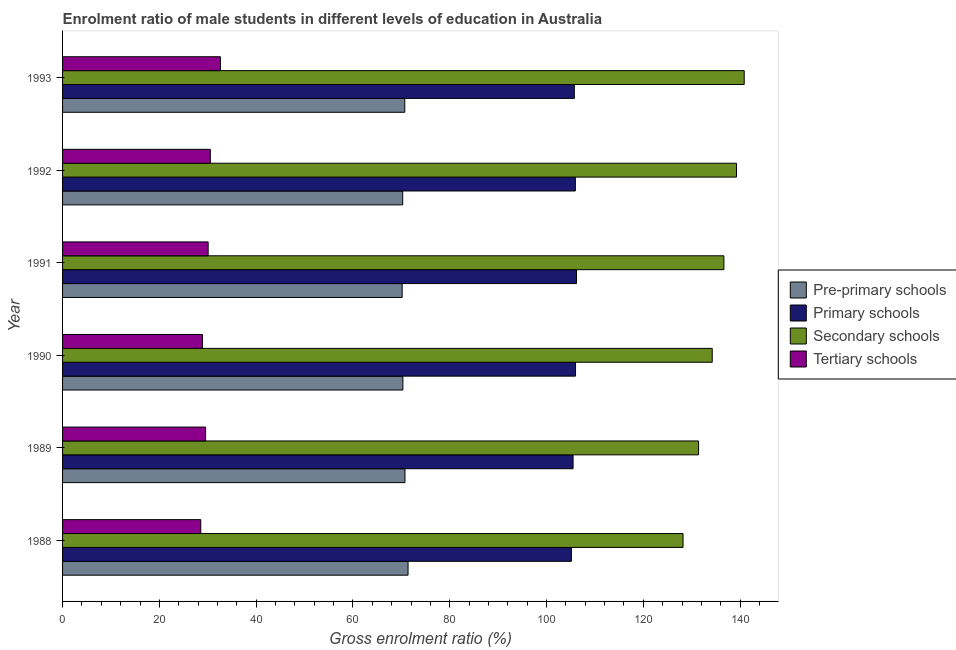How many different coloured bars are there?
Provide a succinct answer. 4. Are the number of bars per tick equal to the number of legend labels?
Make the answer very short. Yes. How many bars are there on the 6th tick from the bottom?
Your answer should be very brief. 4. In how many cases, is the number of bars for a given year not equal to the number of legend labels?
Give a very brief answer. 0. What is the gross enrolment ratio(female) in tertiary schools in 1991?
Make the answer very short. 30.08. Across all years, what is the maximum gross enrolment ratio(female) in primary schools?
Offer a terse response. 106.19. Across all years, what is the minimum gross enrolment ratio(female) in pre-primary schools?
Offer a terse response. 70.17. In which year was the gross enrolment ratio(female) in tertiary schools maximum?
Offer a terse response. 1993. What is the total gross enrolment ratio(female) in secondary schools in the graph?
Your answer should be very brief. 810.62. What is the difference between the gross enrolment ratio(female) in pre-primary schools in 1988 and that in 1989?
Your response must be concise. 0.64. What is the difference between the gross enrolment ratio(female) in tertiary schools in 1990 and the gross enrolment ratio(female) in pre-primary schools in 1993?
Your response must be concise. -41.79. What is the average gross enrolment ratio(female) in pre-primary schools per year?
Provide a short and direct response. 70.6. In the year 1989, what is the difference between the gross enrolment ratio(female) in pre-primary schools and gross enrolment ratio(female) in primary schools?
Offer a terse response. -34.74. What is the ratio of the gross enrolment ratio(female) in secondary schools in 1988 to that in 1990?
Make the answer very short. 0.95. Is the gross enrolment ratio(female) in primary schools in 1992 less than that in 1993?
Offer a terse response. No. Is the difference between the gross enrolment ratio(female) in tertiary schools in 1988 and 1991 greater than the difference between the gross enrolment ratio(female) in primary schools in 1988 and 1991?
Your answer should be compact. No. What is the difference between the highest and the second highest gross enrolment ratio(female) in tertiary schools?
Offer a terse response. 2.08. What is the difference between the highest and the lowest gross enrolment ratio(female) in secondary schools?
Ensure brevity in your answer.  12.64. In how many years, is the gross enrolment ratio(female) in tertiary schools greater than the average gross enrolment ratio(female) in tertiary schools taken over all years?
Offer a terse response. 3. Is the sum of the gross enrolment ratio(female) in tertiary schools in 1988 and 1991 greater than the maximum gross enrolment ratio(female) in secondary schools across all years?
Make the answer very short. No. Is it the case that in every year, the sum of the gross enrolment ratio(female) in pre-primary schools and gross enrolment ratio(female) in tertiary schools is greater than the sum of gross enrolment ratio(female) in primary schools and gross enrolment ratio(female) in secondary schools?
Your answer should be compact. No. What does the 4th bar from the top in 1991 represents?
Offer a terse response. Pre-primary schools. What does the 2nd bar from the bottom in 1991 represents?
Offer a terse response. Primary schools. Is it the case that in every year, the sum of the gross enrolment ratio(female) in pre-primary schools and gross enrolment ratio(female) in primary schools is greater than the gross enrolment ratio(female) in secondary schools?
Your answer should be very brief. Yes. How many bars are there?
Provide a succinct answer. 24. Are all the bars in the graph horizontal?
Offer a terse response. Yes. Are the values on the major ticks of X-axis written in scientific E-notation?
Offer a very short reply. No. Does the graph contain any zero values?
Ensure brevity in your answer.  No. Does the graph contain grids?
Provide a short and direct response. No. Where does the legend appear in the graph?
Ensure brevity in your answer.  Center right. How many legend labels are there?
Your answer should be compact. 4. How are the legend labels stacked?
Offer a very short reply. Vertical. What is the title of the graph?
Keep it short and to the point. Enrolment ratio of male students in different levels of education in Australia. Does "Industry" appear as one of the legend labels in the graph?
Your answer should be very brief. No. What is the label or title of the X-axis?
Offer a terse response. Gross enrolment ratio (%). What is the Gross enrolment ratio (%) in Pre-primary schools in 1988?
Your response must be concise. 71.39. What is the Gross enrolment ratio (%) of Primary schools in 1988?
Give a very brief answer. 105.14. What is the Gross enrolment ratio (%) in Secondary schools in 1988?
Your answer should be very brief. 128.21. What is the Gross enrolment ratio (%) in Tertiary schools in 1988?
Offer a very short reply. 28.56. What is the Gross enrolment ratio (%) of Pre-primary schools in 1989?
Your response must be concise. 70.75. What is the Gross enrolment ratio (%) in Primary schools in 1989?
Your answer should be very brief. 105.49. What is the Gross enrolment ratio (%) of Secondary schools in 1989?
Your answer should be very brief. 131.42. What is the Gross enrolment ratio (%) of Tertiary schools in 1989?
Provide a short and direct response. 29.56. What is the Gross enrolment ratio (%) in Pre-primary schools in 1990?
Your answer should be very brief. 70.32. What is the Gross enrolment ratio (%) of Primary schools in 1990?
Offer a terse response. 105.99. What is the Gross enrolment ratio (%) in Secondary schools in 1990?
Make the answer very short. 134.24. What is the Gross enrolment ratio (%) of Tertiary schools in 1990?
Your response must be concise. 28.92. What is the Gross enrolment ratio (%) of Pre-primary schools in 1991?
Offer a terse response. 70.17. What is the Gross enrolment ratio (%) of Primary schools in 1991?
Keep it short and to the point. 106.19. What is the Gross enrolment ratio (%) of Secondary schools in 1991?
Your response must be concise. 136.65. What is the Gross enrolment ratio (%) in Tertiary schools in 1991?
Give a very brief answer. 30.08. What is the Gross enrolment ratio (%) of Pre-primary schools in 1992?
Keep it short and to the point. 70.28. What is the Gross enrolment ratio (%) in Primary schools in 1992?
Your response must be concise. 105.96. What is the Gross enrolment ratio (%) of Secondary schools in 1992?
Offer a terse response. 139.25. What is the Gross enrolment ratio (%) in Tertiary schools in 1992?
Make the answer very short. 30.53. What is the Gross enrolment ratio (%) of Pre-primary schools in 1993?
Make the answer very short. 70.71. What is the Gross enrolment ratio (%) of Primary schools in 1993?
Ensure brevity in your answer.  105.75. What is the Gross enrolment ratio (%) in Secondary schools in 1993?
Provide a succinct answer. 140.85. What is the Gross enrolment ratio (%) of Tertiary schools in 1993?
Provide a succinct answer. 32.62. Across all years, what is the maximum Gross enrolment ratio (%) of Pre-primary schools?
Offer a terse response. 71.39. Across all years, what is the maximum Gross enrolment ratio (%) of Primary schools?
Offer a very short reply. 106.19. Across all years, what is the maximum Gross enrolment ratio (%) of Secondary schools?
Ensure brevity in your answer.  140.85. Across all years, what is the maximum Gross enrolment ratio (%) in Tertiary schools?
Your answer should be compact. 32.62. Across all years, what is the minimum Gross enrolment ratio (%) in Pre-primary schools?
Your answer should be very brief. 70.17. Across all years, what is the minimum Gross enrolment ratio (%) of Primary schools?
Your answer should be very brief. 105.14. Across all years, what is the minimum Gross enrolment ratio (%) in Secondary schools?
Make the answer very short. 128.21. Across all years, what is the minimum Gross enrolment ratio (%) in Tertiary schools?
Ensure brevity in your answer.  28.56. What is the total Gross enrolment ratio (%) in Pre-primary schools in the graph?
Provide a short and direct response. 423.62. What is the total Gross enrolment ratio (%) of Primary schools in the graph?
Keep it short and to the point. 634.52. What is the total Gross enrolment ratio (%) of Secondary schools in the graph?
Keep it short and to the point. 810.62. What is the total Gross enrolment ratio (%) in Tertiary schools in the graph?
Your answer should be very brief. 180.26. What is the difference between the Gross enrolment ratio (%) of Pre-primary schools in 1988 and that in 1989?
Your answer should be very brief. 0.64. What is the difference between the Gross enrolment ratio (%) in Primary schools in 1988 and that in 1989?
Provide a short and direct response. -0.35. What is the difference between the Gross enrolment ratio (%) in Secondary schools in 1988 and that in 1989?
Provide a short and direct response. -3.21. What is the difference between the Gross enrolment ratio (%) of Tertiary schools in 1988 and that in 1989?
Provide a short and direct response. -1. What is the difference between the Gross enrolment ratio (%) of Pre-primary schools in 1988 and that in 1990?
Offer a very short reply. 1.07. What is the difference between the Gross enrolment ratio (%) of Primary schools in 1988 and that in 1990?
Ensure brevity in your answer.  -0.86. What is the difference between the Gross enrolment ratio (%) in Secondary schools in 1988 and that in 1990?
Offer a terse response. -6.03. What is the difference between the Gross enrolment ratio (%) of Tertiary schools in 1988 and that in 1990?
Provide a short and direct response. -0.36. What is the difference between the Gross enrolment ratio (%) in Pre-primary schools in 1988 and that in 1991?
Give a very brief answer. 1.22. What is the difference between the Gross enrolment ratio (%) of Primary schools in 1988 and that in 1991?
Keep it short and to the point. -1.05. What is the difference between the Gross enrolment ratio (%) of Secondary schools in 1988 and that in 1991?
Keep it short and to the point. -8.45. What is the difference between the Gross enrolment ratio (%) of Tertiary schools in 1988 and that in 1991?
Provide a short and direct response. -1.53. What is the difference between the Gross enrolment ratio (%) of Pre-primary schools in 1988 and that in 1992?
Your answer should be very brief. 1.11. What is the difference between the Gross enrolment ratio (%) of Primary schools in 1988 and that in 1992?
Give a very brief answer. -0.82. What is the difference between the Gross enrolment ratio (%) in Secondary schools in 1988 and that in 1992?
Provide a short and direct response. -11.05. What is the difference between the Gross enrolment ratio (%) in Tertiary schools in 1988 and that in 1992?
Offer a very short reply. -1.98. What is the difference between the Gross enrolment ratio (%) in Pre-primary schools in 1988 and that in 1993?
Your answer should be compact. 0.68. What is the difference between the Gross enrolment ratio (%) in Primary schools in 1988 and that in 1993?
Offer a terse response. -0.61. What is the difference between the Gross enrolment ratio (%) in Secondary schools in 1988 and that in 1993?
Provide a short and direct response. -12.64. What is the difference between the Gross enrolment ratio (%) of Tertiary schools in 1988 and that in 1993?
Make the answer very short. -4.06. What is the difference between the Gross enrolment ratio (%) in Pre-primary schools in 1989 and that in 1990?
Your answer should be very brief. 0.43. What is the difference between the Gross enrolment ratio (%) in Primary schools in 1989 and that in 1990?
Provide a succinct answer. -0.51. What is the difference between the Gross enrolment ratio (%) of Secondary schools in 1989 and that in 1990?
Give a very brief answer. -2.82. What is the difference between the Gross enrolment ratio (%) of Tertiary schools in 1989 and that in 1990?
Your answer should be very brief. 0.64. What is the difference between the Gross enrolment ratio (%) of Pre-primary schools in 1989 and that in 1991?
Provide a succinct answer. 0.58. What is the difference between the Gross enrolment ratio (%) of Primary schools in 1989 and that in 1991?
Your answer should be compact. -0.7. What is the difference between the Gross enrolment ratio (%) in Secondary schools in 1989 and that in 1991?
Provide a short and direct response. -5.23. What is the difference between the Gross enrolment ratio (%) of Tertiary schools in 1989 and that in 1991?
Ensure brevity in your answer.  -0.53. What is the difference between the Gross enrolment ratio (%) in Pre-primary schools in 1989 and that in 1992?
Make the answer very short. 0.47. What is the difference between the Gross enrolment ratio (%) of Primary schools in 1989 and that in 1992?
Make the answer very short. -0.47. What is the difference between the Gross enrolment ratio (%) in Secondary schools in 1989 and that in 1992?
Your answer should be compact. -7.84. What is the difference between the Gross enrolment ratio (%) in Tertiary schools in 1989 and that in 1992?
Offer a terse response. -0.98. What is the difference between the Gross enrolment ratio (%) in Pre-primary schools in 1989 and that in 1993?
Offer a terse response. 0.04. What is the difference between the Gross enrolment ratio (%) in Primary schools in 1989 and that in 1993?
Make the answer very short. -0.26. What is the difference between the Gross enrolment ratio (%) in Secondary schools in 1989 and that in 1993?
Offer a very short reply. -9.43. What is the difference between the Gross enrolment ratio (%) in Tertiary schools in 1989 and that in 1993?
Ensure brevity in your answer.  -3.06. What is the difference between the Gross enrolment ratio (%) of Pre-primary schools in 1990 and that in 1991?
Keep it short and to the point. 0.15. What is the difference between the Gross enrolment ratio (%) in Primary schools in 1990 and that in 1991?
Your answer should be very brief. -0.2. What is the difference between the Gross enrolment ratio (%) of Secondary schools in 1990 and that in 1991?
Keep it short and to the point. -2.41. What is the difference between the Gross enrolment ratio (%) in Tertiary schools in 1990 and that in 1991?
Your answer should be very brief. -1.17. What is the difference between the Gross enrolment ratio (%) in Pre-primary schools in 1990 and that in 1992?
Keep it short and to the point. 0.03. What is the difference between the Gross enrolment ratio (%) in Primary schools in 1990 and that in 1992?
Your answer should be compact. 0.04. What is the difference between the Gross enrolment ratio (%) of Secondary schools in 1990 and that in 1992?
Make the answer very short. -5.01. What is the difference between the Gross enrolment ratio (%) of Tertiary schools in 1990 and that in 1992?
Offer a very short reply. -1.62. What is the difference between the Gross enrolment ratio (%) in Pre-primary schools in 1990 and that in 1993?
Provide a succinct answer. -0.39. What is the difference between the Gross enrolment ratio (%) of Primary schools in 1990 and that in 1993?
Offer a terse response. 0.25. What is the difference between the Gross enrolment ratio (%) of Secondary schools in 1990 and that in 1993?
Keep it short and to the point. -6.61. What is the difference between the Gross enrolment ratio (%) of Tertiary schools in 1990 and that in 1993?
Provide a succinct answer. -3.7. What is the difference between the Gross enrolment ratio (%) in Pre-primary schools in 1991 and that in 1992?
Offer a very short reply. -0.11. What is the difference between the Gross enrolment ratio (%) of Primary schools in 1991 and that in 1992?
Provide a succinct answer. 0.23. What is the difference between the Gross enrolment ratio (%) of Secondary schools in 1991 and that in 1992?
Offer a terse response. -2.6. What is the difference between the Gross enrolment ratio (%) of Tertiary schools in 1991 and that in 1992?
Provide a short and direct response. -0.45. What is the difference between the Gross enrolment ratio (%) of Pre-primary schools in 1991 and that in 1993?
Ensure brevity in your answer.  -0.54. What is the difference between the Gross enrolment ratio (%) in Primary schools in 1991 and that in 1993?
Your response must be concise. 0.44. What is the difference between the Gross enrolment ratio (%) in Secondary schools in 1991 and that in 1993?
Offer a terse response. -4.19. What is the difference between the Gross enrolment ratio (%) in Tertiary schools in 1991 and that in 1993?
Your response must be concise. -2.53. What is the difference between the Gross enrolment ratio (%) in Pre-primary schools in 1992 and that in 1993?
Offer a terse response. -0.43. What is the difference between the Gross enrolment ratio (%) in Primary schools in 1992 and that in 1993?
Provide a succinct answer. 0.21. What is the difference between the Gross enrolment ratio (%) of Secondary schools in 1992 and that in 1993?
Offer a terse response. -1.59. What is the difference between the Gross enrolment ratio (%) in Tertiary schools in 1992 and that in 1993?
Make the answer very short. -2.08. What is the difference between the Gross enrolment ratio (%) in Pre-primary schools in 1988 and the Gross enrolment ratio (%) in Primary schools in 1989?
Keep it short and to the point. -34.1. What is the difference between the Gross enrolment ratio (%) in Pre-primary schools in 1988 and the Gross enrolment ratio (%) in Secondary schools in 1989?
Ensure brevity in your answer.  -60.03. What is the difference between the Gross enrolment ratio (%) of Pre-primary schools in 1988 and the Gross enrolment ratio (%) of Tertiary schools in 1989?
Offer a very short reply. 41.83. What is the difference between the Gross enrolment ratio (%) in Primary schools in 1988 and the Gross enrolment ratio (%) in Secondary schools in 1989?
Offer a terse response. -26.28. What is the difference between the Gross enrolment ratio (%) of Primary schools in 1988 and the Gross enrolment ratio (%) of Tertiary schools in 1989?
Provide a short and direct response. 75.58. What is the difference between the Gross enrolment ratio (%) of Secondary schools in 1988 and the Gross enrolment ratio (%) of Tertiary schools in 1989?
Your response must be concise. 98.65. What is the difference between the Gross enrolment ratio (%) in Pre-primary schools in 1988 and the Gross enrolment ratio (%) in Primary schools in 1990?
Offer a very short reply. -34.61. What is the difference between the Gross enrolment ratio (%) of Pre-primary schools in 1988 and the Gross enrolment ratio (%) of Secondary schools in 1990?
Your response must be concise. -62.85. What is the difference between the Gross enrolment ratio (%) of Pre-primary schools in 1988 and the Gross enrolment ratio (%) of Tertiary schools in 1990?
Your answer should be very brief. 42.47. What is the difference between the Gross enrolment ratio (%) of Primary schools in 1988 and the Gross enrolment ratio (%) of Secondary schools in 1990?
Ensure brevity in your answer.  -29.1. What is the difference between the Gross enrolment ratio (%) in Primary schools in 1988 and the Gross enrolment ratio (%) in Tertiary schools in 1990?
Your answer should be compact. 76.22. What is the difference between the Gross enrolment ratio (%) in Secondary schools in 1988 and the Gross enrolment ratio (%) in Tertiary schools in 1990?
Your response must be concise. 99.29. What is the difference between the Gross enrolment ratio (%) in Pre-primary schools in 1988 and the Gross enrolment ratio (%) in Primary schools in 1991?
Your answer should be very brief. -34.8. What is the difference between the Gross enrolment ratio (%) in Pre-primary schools in 1988 and the Gross enrolment ratio (%) in Secondary schools in 1991?
Offer a very short reply. -65.26. What is the difference between the Gross enrolment ratio (%) of Pre-primary schools in 1988 and the Gross enrolment ratio (%) of Tertiary schools in 1991?
Make the answer very short. 41.3. What is the difference between the Gross enrolment ratio (%) in Primary schools in 1988 and the Gross enrolment ratio (%) in Secondary schools in 1991?
Keep it short and to the point. -31.52. What is the difference between the Gross enrolment ratio (%) in Primary schools in 1988 and the Gross enrolment ratio (%) in Tertiary schools in 1991?
Provide a short and direct response. 75.05. What is the difference between the Gross enrolment ratio (%) of Secondary schools in 1988 and the Gross enrolment ratio (%) of Tertiary schools in 1991?
Offer a terse response. 98.12. What is the difference between the Gross enrolment ratio (%) in Pre-primary schools in 1988 and the Gross enrolment ratio (%) in Primary schools in 1992?
Provide a succinct answer. -34.57. What is the difference between the Gross enrolment ratio (%) of Pre-primary schools in 1988 and the Gross enrolment ratio (%) of Secondary schools in 1992?
Your answer should be compact. -67.87. What is the difference between the Gross enrolment ratio (%) in Pre-primary schools in 1988 and the Gross enrolment ratio (%) in Tertiary schools in 1992?
Offer a very short reply. 40.85. What is the difference between the Gross enrolment ratio (%) of Primary schools in 1988 and the Gross enrolment ratio (%) of Secondary schools in 1992?
Ensure brevity in your answer.  -34.12. What is the difference between the Gross enrolment ratio (%) of Primary schools in 1988 and the Gross enrolment ratio (%) of Tertiary schools in 1992?
Keep it short and to the point. 74.6. What is the difference between the Gross enrolment ratio (%) of Secondary schools in 1988 and the Gross enrolment ratio (%) of Tertiary schools in 1992?
Keep it short and to the point. 97.67. What is the difference between the Gross enrolment ratio (%) in Pre-primary schools in 1988 and the Gross enrolment ratio (%) in Primary schools in 1993?
Provide a succinct answer. -34.36. What is the difference between the Gross enrolment ratio (%) of Pre-primary schools in 1988 and the Gross enrolment ratio (%) of Secondary schools in 1993?
Offer a terse response. -69.46. What is the difference between the Gross enrolment ratio (%) in Pre-primary schools in 1988 and the Gross enrolment ratio (%) in Tertiary schools in 1993?
Your answer should be compact. 38.77. What is the difference between the Gross enrolment ratio (%) in Primary schools in 1988 and the Gross enrolment ratio (%) in Secondary schools in 1993?
Offer a very short reply. -35.71. What is the difference between the Gross enrolment ratio (%) in Primary schools in 1988 and the Gross enrolment ratio (%) in Tertiary schools in 1993?
Offer a terse response. 72.52. What is the difference between the Gross enrolment ratio (%) in Secondary schools in 1988 and the Gross enrolment ratio (%) in Tertiary schools in 1993?
Ensure brevity in your answer.  95.59. What is the difference between the Gross enrolment ratio (%) in Pre-primary schools in 1989 and the Gross enrolment ratio (%) in Primary schools in 1990?
Provide a succinct answer. -35.24. What is the difference between the Gross enrolment ratio (%) in Pre-primary schools in 1989 and the Gross enrolment ratio (%) in Secondary schools in 1990?
Make the answer very short. -63.49. What is the difference between the Gross enrolment ratio (%) in Pre-primary schools in 1989 and the Gross enrolment ratio (%) in Tertiary schools in 1990?
Your answer should be compact. 41.83. What is the difference between the Gross enrolment ratio (%) in Primary schools in 1989 and the Gross enrolment ratio (%) in Secondary schools in 1990?
Offer a very short reply. -28.75. What is the difference between the Gross enrolment ratio (%) in Primary schools in 1989 and the Gross enrolment ratio (%) in Tertiary schools in 1990?
Your answer should be compact. 76.57. What is the difference between the Gross enrolment ratio (%) of Secondary schools in 1989 and the Gross enrolment ratio (%) of Tertiary schools in 1990?
Ensure brevity in your answer.  102.5. What is the difference between the Gross enrolment ratio (%) in Pre-primary schools in 1989 and the Gross enrolment ratio (%) in Primary schools in 1991?
Your response must be concise. -35.44. What is the difference between the Gross enrolment ratio (%) in Pre-primary schools in 1989 and the Gross enrolment ratio (%) in Secondary schools in 1991?
Keep it short and to the point. -65.9. What is the difference between the Gross enrolment ratio (%) in Pre-primary schools in 1989 and the Gross enrolment ratio (%) in Tertiary schools in 1991?
Make the answer very short. 40.67. What is the difference between the Gross enrolment ratio (%) in Primary schools in 1989 and the Gross enrolment ratio (%) in Secondary schools in 1991?
Provide a short and direct response. -31.17. What is the difference between the Gross enrolment ratio (%) in Primary schools in 1989 and the Gross enrolment ratio (%) in Tertiary schools in 1991?
Make the answer very short. 75.4. What is the difference between the Gross enrolment ratio (%) of Secondary schools in 1989 and the Gross enrolment ratio (%) of Tertiary schools in 1991?
Make the answer very short. 101.33. What is the difference between the Gross enrolment ratio (%) of Pre-primary schools in 1989 and the Gross enrolment ratio (%) of Primary schools in 1992?
Ensure brevity in your answer.  -35.21. What is the difference between the Gross enrolment ratio (%) of Pre-primary schools in 1989 and the Gross enrolment ratio (%) of Secondary schools in 1992?
Keep it short and to the point. -68.5. What is the difference between the Gross enrolment ratio (%) in Pre-primary schools in 1989 and the Gross enrolment ratio (%) in Tertiary schools in 1992?
Ensure brevity in your answer.  40.22. What is the difference between the Gross enrolment ratio (%) of Primary schools in 1989 and the Gross enrolment ratio (%) of Secondary schools in 1992?
Ensure brevity in your answer.  -33.77. What is the difference between the Gross enrolment ratio (%) of Primary schools in 1989 and the Gross enrolment ratio (%) of Tertiary schools in 1992?
Your answer should be compact. 74.95. What is the difference between the Gross enrolment ratio (%) in Secondary schools in 1989 and the Gross enrolment ratio (%) in Tertiary schools in 1992?
Offer a terse response. 100.89. What is the difference between the Gross enrolment ratio (%) in Pre-primary schools in 1989 and the Gross enrolment ratio (%) in Primary schools in 1993?
Your answer should be compact. -35. What is the difference between the Gross enrolment ratio (%) in Pre-primary schools in 1989 and the Gross enrolment ratio (%) in Secondary schools in 1993?
Provide a succinct answer. -70.1. What is the difference between the Gross enrolment ratio (%) of Pre-primary schools in 1989 and the Gross enrolment ratio (%) of Tertiary schools in 1993?
Provide a succinct answer. 38.13. What is the difference between the Gross enrolment ratio (%) in Primary schools in 1989 and the Gross enrolment ratio (%) in Secondary schools in 1993?
Give a very brief answer. -35.36. What is the difference between the Gross enrolment ratio (%) in Primary schools in 1989 and the Gross enrolment ratio (%) in Tertiary schools in 1993?
Your answer should be very brief. 72.87. What is the difference between the Gross enrolment ratio (%) in Secondary schools in 1989 and the Gross enrolment ratio (%) in Tertiary schools in 1993?
Your response must be concise. 98.8. What is the difference between the Gross enrolment ratio (%) in Pre-primary schools in 1990 and the Gross enrolment ratio (%) in Primary schools in 1991?
Ensure brevity in your answer.  -35.87. What is the difference between the Gross enrolment ratio (%) in Pre-primary schools in 1990 and the Gross enrolment ratio (%) in Secondary schools in 1991?
Your answer should be very brief. -66.34. What is the difference between the Gross enrolment ratio (%) of Pre-primary schools in 1990 and the Gross enrolment ratio (%) of Tertiary schools in 1991?
Offer a very short reply. 40.23. What is the difference between the Gross enrolment ratio (%) of Primary schools in 1990 and the Gross enrolment ratio (%) of Secondary schools in 1991?
Make the answer very short. -30.66. What is the difference between the Gross enrolment ratio (%) of Primary schools in 1990 and the Gross enrolment ratio (%) of Tertiary schools in 1991?
Give a very brief answer. 75.91. What is the difference between the Gross enrolment ratio (%) of Secondary schools in 1990 and the Gross enrolment ratio (%) of Tertiary schools in 1991?
Your answer should be compact. 104.16. What is the difference between the Gross enrolment ratio (%) in Pre-primary schools in 1990 and the Gross enrolment ratio (%) in Primary schools in 1992?
Keep it short and to the point. -35.64. What is the difference between the Gross enrolment ratio (%) in Pre-primary schools in 1990 and the Gross enrolment ratio (%) in Secondary schools in 1992?
Ensure brevity in your answer.  -68.94. What is the difference between the Gross enrolment ratio (%) in Pre-primary schools in 1990 and the Gross enrolment ratio (%) in Tertiary schools in 1992?
Keep it short and to the point. 39.78. What is the difference between the Gross enrolment ratio (%) of Primary schools in 1990 and the Gross enrolment ratio (%) of Secondary schools in 1992?
Your answer should be very brief. -33.26. What is the difference between the Gross enrolment ratio (%) in Primary schools in 1990 and the Gross enrolment ratio (%) in Tertiary schools in 1992?
Keep it short and to the point. 75.46. What is the difference between the Gross enrolment ratio (%) of Secondary schools in 1990 and the Gross enrolment ratio (%) of Tertiary schools in 1992?
Provide a short and direct response. 103.71. What is the difference between the Gross enrolment ratio (%) of Pre-primary schools in 1990 and the Gross enrolment ratio (%) of Primary schools in 1993?
Give a very brief answer. -35.43. What is the difference between the Gross enrolment ratio (%) in Pre-primary schools in 1990 and the Gross enrolment ratio (%) in Secondary schools in 1993?
Your answer should be very brief. -70.53. What is the difference between the Gross enrolment ratio (%) in Pre-primary schools in 1990 and the Gross enrolment ratio (%) in Tertiary schools in 1993?
Offer a terse response. 37.7. What is the difference between the Gross enrolment ratio (%) of Primary schools in 1990 and the Gross enrolment ratio (%) of Secondary schools in 1993?
Your response must be concise. -34.85. What is the difference between the Gross enrolment ratio (%) of Primary schools in 1990 and the Gross enrolment ratio (%) of Tertiary schools in 1993?
Provide a short and direct response. 73.38. What is the difference between the Gross enrolment ratio (%) in Secondary schools in 1990 and the Gross enrolment ratio (%) in Tertiary schools in 1993?
Keep it short and to the point. 101.62. What is the difference between the Gross enrolment ratio (%) of Pre-primary schools in 1991 and the Gross enrolment ratio (%) of Primary schools in 1992?
Give a very brief answer. -35.79. What is the difference between the Gross enrolment ratio (%) in Pre-primary schools in 1991 and the Gross enrolment ratio (%) in Secondary schools in 1992?
Ensure brevity in your answer.  -69.09. What is the difference between the Gross enrolment ratio (%) of Pre-primary schools in 1991 and the Gross enrolment ratio (%) of Tertiary schools in 1992?
Your answer should be compact. 39.64. What is the difference between the Gross enrolment ratio (%) in Primary schools in 1991 and the Gross enrolment ratio (%) in Secondary schools in 1992?
Provide a short and direct response. -33.06. What is the difference between the Gross enrolment ratio (%) in Primary schools in 1991 and the Gross enrolment ratio (%) in Tertiary schools in 1992?
Keep it short and to the point. 75.66. What is the difference between the Gross enrolment ratio (%) in Secondary schools in 1991 and the Gross enrolment ratio (%) in Tertiary schools in 1992?
Offer a very short reply. 106.12. What is the difference between the Gross enrolment ratio (%) of Pre-primary schools in 1991 and the Gross enrolment ratio (%) of Primary schools in 1993?
Give a very brief answer. -35.58. What is the difference between the Gross enrolment ratio (%) in Pre-primary schools in 1991 and the Gross enrolment ratio (%) in Secondary schools in 1993?
Your answer should be very brief. -70.68. What is the difference between the Gross enrolment ratio (%) of Pre-primary schools in 1991 and the Gross enrolment ratio (%) of Tertiary schools in 1993?
Provide a succinct answer. 37.55. What is the difference between the Gross enrolment ratio (%) in Primary schools in 1991 and the Gross enrolment ratio (%) in Secondary schools in 1993?
Keep it short and to the point. -34.66. What is the difference between the Gross enrolment ratio (%) of Primary schools in 1991 and the Gross enrolment ratio (%) of Tertiary schools in 1993?
Offer a very short reply. 73.57. What is the difference between the Gross enrolment ratio (%) of Secondary schools in 1991 and the Gross enrolment ratio (%) of Tertiary schools in 1993?
Your response must be concise. 104.04. What is the difference between the Gross enrolment ratio (%) of Pre-primary schools in 1992 and the Gross enrolment ratio (%) of Primary schools in 1993?
Your answer should be compact. -35.46. What is the difference between the Gross enrolment ratio (%) of Pre-primary schools in 1992 and the Gross enrolment ratio (%) of Secondary schools in 1993?
Your response must be concise. -70.56. What is the difference between the Gross enrolment ratio (%) in Pre-primary schools in 1992 and the Gross enrolment ratio (%) in Tertiary schools in 1993?
Your answer should be compact. 37.67. What is the difference between the Gross enrolment ratio (%) of Primary schools in 1992 and the Gross enrolment ratio (%) of Secondary schools in 1993?
Offer a very short reply. -34.89. What is the difference between the Gross enrolment ratio (%) of Primary schools in 1992 and the Gross enrolment ratio (%) of Tertiary schools in 1993?
Your answer should be very brief. 73.34. What is the difference between the Gross enrolment ratio (%) of Secondary schools in 1992 and the Gross enrolment ratio (%) of Tertiary schools in 1993?
Provide a short and direct response. 106.64. What is the average Gross enrolment ratio (%) in Pre-primary schools per year?
Provide a short and direct response. 70.6. What is the average Gross enrolment ratio (%) in Primary schools per year?
Keep it short and to the point. 105.75. What is the average Gross enrolment ratio (%) of Secondary schools per year?
Make the answer very short. 135.1. What is the average Gross enrolment ratio (%) in Tertiary schools per year?
Give a very brief answer. 30.04. In the year 1988, what is the difference between the Gross enrolment ratio (%) in Pre-primary schools and Gross enrolment ratio (%) in Primary schools?
Provide a short and direct response. -33.75. In the year 1988, what is the difference between the Gross enrolment ratio (%) of Pre-primary schools and Gross enrolment ratio (%) of Secondary schools?
Provide a succinct answer. -56.82. In the year 1988, what is the difference between the Gross enrolment ratio (%) of Pre-primary schools and Gross enrolment ratio (%) of Tertiary schools?
Your answer should be very brief. 42.83. In the year 1988, what is the difference between the Gross enrolment ratio (%) of Primary schools and Gross enrolment ratio (%) of Secondary schools?
Make the answer very short. -23.07. In the year 1988, what is the difference between the Gross enrolment ratio (%) of Primary schools and Gross enrolment ratio (%) of Tertiary schools?
Ensure brevity in your answer.  76.58. In the year 1988, what is the difference between the Gross enrolment ratio (%) in Secondary schools and Gross enrolment ratio (%) in Tertiary schools?
Your answer should be compact. 99.65. In the year 1989, what is the difference between the Gross enrolment ratio (%) in Pre-primary schools and Gross enrolment ratio (%) in Primary schools?
Offer a terse response. -34.74. In the year 1989, what is the difference between the Gross enrolment ratio (%) in Pre-primary schools and Gross enrolment ratio (%) in Secondary schools?
Provide a succinct answer. -60.67. In the year 1989, what is the difference between the Gross enrolment ratio (%) in Pre-primary schools and Gross enrolment ratio (%) in Tertiary schools?
Your response must be concise. 41.19. In the year 1989, what is the difference between the Gross enrolment ratio (%) in Primary schools and Gross enrolment ratio (%) in Secondary schools?
Keep it short and to the point. -25.93. In the year 1989, what is the difference between the Gross enrolment ratio (%) in Primary schools and Gross enrolment ratio (%) in Tertiary schools?
Ensure brevity in your answer.  75.93. In the year 1989, what is the difference between the Gross enrolment ratio (%) in Secondary schools and Gross enrolment ratio (%) in Tertiary schools?
Your answer should be compact. 101.86. In the year 1990, what is the difference between the Gross enrolment ratio (%) of Pre-primary schools and Gross enrolment ratio (%) of Primary schools?
Offer a very short reply. -35.68. In the year 1990, what is the difference between the Gross enrolment ratio (%) of Pre-primary schools and Gross enrolment ratio (%) of Secondary schools?
Your answer should be very brief. -63.92. In the year 1990, what is the difference between the Gross enrolment ratio (%) in Pre-primary schools and Gross enrolment ratio (%) in Tertiary schools?
Provide a succinct answer. 41.4. In the year 1990, what is the difference between the Gross enrolment ratio (%) of Primary schools and Gross enrolment ratio (%) of Secondary schools?
Give a very brief answer. -28.25. In the year 1990, what is the difference between the Gross enrolment ratio (%) in Primary schools and Gross enrolment ratio (%) in Tertiary schools?
Ensure brevity in your answer.  77.08. In the year 1990, what is the difference between the Gross enrolment ratio (%) of Secondary schools and Gross enrolment ratio (%) of Tertiary schools?
Keep it short and to the point. 105.32. In the year 1991, what is the difference between the Gross enrolment ratio (%) of Pre-primary schools and Gross enrolment ratio (%) of Primary schools?
Keep it short and to the point. -36.02. In the year 1991, what is the difference between the Gross enrolment ratio (%) of Pre-primary schools and Gross enrolment ratio (%) of Secondary schools?
Your answer should be very brief. -66.48. In the year 1991, what is the difference between the Gross enrolment ratio (%) in Pre-primary schools and Gross enrolment ratio (%) in Tertiary schools?
Provide a succinct answer. 40.08. In the year 1991, what is the difference between the Gross enrolment ratio (%) of Primary schools and Gross enrolment ratio (%) of Secondary schools?
Give a very brief answer. -30.46. In the year 1991, what is the difference between the Gross enrolment ratio (%) of Primary schools and Gross enrolment ratio (%) of Tertiary schools?
Your answer should be compact. 76.11. In the year 1991, what is the difference between the Gross enrolment ratio (%) of Secondary schools and Gross enrolment ratio (%) of Tertiary schools?
Your answer should be very brief. 106.57. In the year 1992, what is the difference between the Gross enrolment ratio (%) in Pre-primary schools and Gross enrolment ratio (%) in Primary schools?
Your answer should be compact. -35.68. In the year 1992, what is the difference between the Gross enrolment ratio (%) in Pre-primary schools and Gross enrolment ratio (%) in Secondary schools?
Give a very brief answer. -68.97. In the year 1992, what is the difference between the Gross enrolment ratio (%) in Pre-primary schools and Gross enrolment ratio (%) in Tertiary schools?
Keep it short and to the point. 39.75. In the year 1992, what is the difference between the Gross enrolment ratio (%) of Primary schools and Gross enrolment ratio (%) of Secondary schools?
Make the answer very short. -33.3. In the year 1992, what is the difference between the Gross enrolment ratio (%) of Primary schools and Gross enrolment ratio (%) of Tertiary schools?
Your response must be concise. 75.42. In the year 1992, what is the difference between the Gross enrolment ratio (%) of Secondary schools and Gross enrolment ratio (%) of Tertiary schools?
Offer a terse response. 108.72. In the year 1993, what is the difference between the Gross enrolment ratio (%) in Pre-primary schools and Gross enrolment ratio (%) in Primary schools?
Your response must be concise. -35.04. In the year 1993, what is the difference between the Gross enrolment ratio (%) of Pre-primary schools and Gross enrolment ratio (%) of Secondary schools?
Provide a short and direct response. -70.14. In the year 1993, what is the difference between the Gross enrolment ratio (%) of Pre-primary schools and Gross enrolment ratio (%) of Tertiary schools?
Your response must be concise. 38.09. In the year 1993, what is the difference between the Gross enrolment ratio (%) of Primary schools and Gross enrolment ratio (%) of Secondary schools?
Your answer should be very brief. -35.1. In the year 1993, what is the difference between the Gross enrolment ratio (%) in Primary schools and Gross enrolment ratio (%) in Tertiary schools?
Offer a very short reply. 73.13. In the year 1993, what is the difference between the Gross enrolment ratio (%) in Secondary schools and Gross enrolment ratio (%) in Tertiary schools?
Make the answer very short. 108.23. What is the ratio of the Gross enrolment ratio (%) in Secondary schools in 1988 to that in 1989?
Make the answer very short. 0.98. What is the ratio of the Gross enrolment ratio (%) of Tertiary schools in 1988 to that in 1989?
Provide a succinct answer. 0.97. What is the ratio of the Gross enrolment ratio (%) in Pre-primary schools in 1988 to that in 1990?
Provide a short and direct response. 1.02. What is the ratio of the Gross enrolment ratio (%) in Primary schools in 1988 to that in 1990?
Ensure brevity in your answer.  0.99. What is the ratio of the Gross enrolment ratio (%) in Secondary schools in 1988 to that in 1990?
Provide a succinct answer. 0.96. What is the ratio of the Gross enrolment ratio (%) in Tertiary schools in 1988 to that in 1990?
Keep it short and to the point. 0.99. What is the ratio of the Gross enrolment ratio (%) of Pre-primary schools in 1988 to that in 1991?
Make the answer very short. 1.02. What is the ratio of the Gross enrolment ratio (%) of Primary schools in 1988 to that in 1991?
Your answer should be very brief. 0.99. What is the ratio of the Gross enrolment ratio (%) of Secondary schools in 1988 to that in 1991?
Give a very brief answer. 0.94. What is the ratio of the Gross enrolment ratio (%) in Tertiary schools in 1988 to that in 1991?
Your response must be concise. 0.95. What is the ratio of the Gross enrolment ratio (%) in Pre-primary schools in 1988 to that in 1992?
Provide a succinct answer. 1.02. What is the ratio of the Gross enrolment ratio (%) of Secondary schools in 1988 to that in 1992?
Your answer should be very brief. 0.92. What is the ratio of the Gross enrolment ratio (%) in Tertiary schools in 1988 to that in 1992?
Your answer should be very brief. 0.94. What is the ratio of the Gross enrolment ratio (%) of Pre-primary schools in 1988 to that in 1993?
Ensure brevity in your answer.  1.01. What is the ratio of the Gross enrolment ratio (%) in Primary schools in 1988 to that in 1993?
Make the answer very short. 0.99. What is the ratio of the Gross enrolment ratio (%) in Secondary schools in 1988 to that in 1993?
Give a very brief answer. 0.91. What is the ratio of the Gross enrolment ratio (%) in Tertiary schools in 1988 to that in 1993?
Keep it short and to the point. 0.88. What is the ratio of the Gross enrolment ratio (%) of Primary schools in 1989 to that in 1990?
Keep it short and to the point. 1. What is the ratio of the Gross enrolment ratio (%) of Tertiary schools in 1989 to that in 1990?
Provide a short and direct response. 1.02. What is the ratio of the Gross enrolment ratio (%) of Pre-primary schools in 1989 to that in 1991?
Ensure brevity in your answer.  1.01. What is the ratio of the Gross enrolment ratio (%) of Secondary schools in 1989 to that in 1991?
Provide a succinct answer. 0.96. What is the ratio of the Gross enrolment ratio (%) in Tertiary schools in 1989 to that in 1991?
Keep it short and to the point. 0.98. What is the ratio of the Gross enrolment ratio (%) of Pre-primary schools in 1989 to that in 1992?
Your answer should be compact. 1.01. What is the ratio of the Gross enrolment ratio (%) in Primary schools in 1989 to that in 1992?
Your response must be concise. 1. What is the ratio of the Gross enrolment ratio (%) in Secondary schools in 1989 to that in 1992?
Give a very brief answer. 0.94. What is the ratio of the Gross enrolment ratio (%) of Tertiary schools in 1989 to that in 1992?
Ensure brevity in your answer.  0.97. What is the ratio of the Gross enrolment ratio (%) of Pre-primary schools in 1989 to that in 1993?
Keep it short and to the point. 1. What is the ratio of the Gross enrolment ratio (%) in Secondary schools in 1989 to that in 1993?
Your answer should be compact. 0.93. What is the ratio of the Gross enrolment ratio (%) in Tertiary schools in 1989 to that in 1993?
Keep it short and to the point. 0.91. What is the ratio of the Gross enrolment ratio (%) in Pre-primary schools in 1990 to that in 1991?
Provide a succinct answer. 1. What is the ratio of the Gross enrolment ratio (%) in Secondary schools in 1990 to that in 1991?
Offer a very short reply. 0.98. What is the ratio of the Gross enrolment ratio (%) of Tertiary schools in 1990 to that in 1991?
Keep it short and to the point. 0.96. What is the ratio of the Gross enrolment ratio (%) in Pre-primary schools in 1990 to that in 1992?
Ensure brevity in your answer.  1. What is the ratio of the Gross enrolment ratio (%) of Primary schools in 1990 to that in 1992?
Ensure brevity in your answer.  1. What is the ratio of the Gross enrolment ratio (%) in Secondary schools in 1990 to that in 1992?
Provide a short and direct response. 0.96. What is the ratio of the Gross enrolment ratio (%) in Tertiary schools in 1990 to that in 1992?
Give a very brief answer. 0.95. What is the ratio of the Gross enrolment ratio (%) in Primary schools in 1990 to that in 1993?
Your answer should be compact. 1. What is the ratio of the Gross enrolment ratio (%) in Secondary schools in 1990 to that in 1993?
Your response must be concise. 0.95. What is the ratio of the Gross enrolment ratio (%) of Tertiary schools in 1990 to that in 1993?
Your response must be concise. 0.89. What is the ratio of the Gross enrolment ratio (%) in Secondary schools in 1991 to that in 1992?
Ensure brevity in your answer.  0.98. What is the ratio of the Gross enrolment ratio (%) of Tertiary schools in 1991 to that in 1992?
Provide a short and direct response. 0.99. What is the ratio of the Gross enrolment ratio (%) in Secondary schools in 1991 to that in 1993?
Your response must be concise. 0.97. What is the ratio of the Gross enrolment ratio (%) in Tertiary schools in 1991 to that in 1993?
Give a very brief answer. 0.92. What is the ratio of the Gross enrolment ratio (%) in Primary schools in 1992 to that in 1993?
Your answer should be very brief. 1. What is the ratio of the Gross enrolment ratio (%) in Secondary schools in 1992 to that in 1993?
Offer a terse response. 0.99. What is the ratio of the Gross enrolment ratio (%) of Tertiary schools in 1992 to that in 1993?
Keep it short and to the point. 0.94. What is the difference between the highest and the second highest Gross enrolment ratio (%) in Pre-primary schools?
Your answer should be very brief. 0.64. What is the difference between the highest and the second highest Gross enrolment ratio (%) of Primary schools?
Your answer should be compact. 0.2. What is the difference between the highest and the second highest Gross enrolment ratio (%) of Secondary schools?
Offer a very short reply. 1.59. What is the difference between the highest and the second highest Gross enrolment ratio (%) in Tertiary schools?
Your answer should be compact. 2.08. What is the difference between the highest and the lowest Gross enrolment ratio (%) of Pre-primary schools?
Your response must be concise. 1.22. What is the difference between the highest and the lowest Gross enrolment ratio (%) of Primary schools?
Make the answer very short. 1.05. What is the difference between the highest and the lowest Gross enrolment ratio (%) of Secondary schools?
Give a very brief answer. 12.64. What is the difference between the highest and the lowest Gross enrolment ratio (%) of Tertiary schools?
Ensure brevity in your answer.  4.06. 